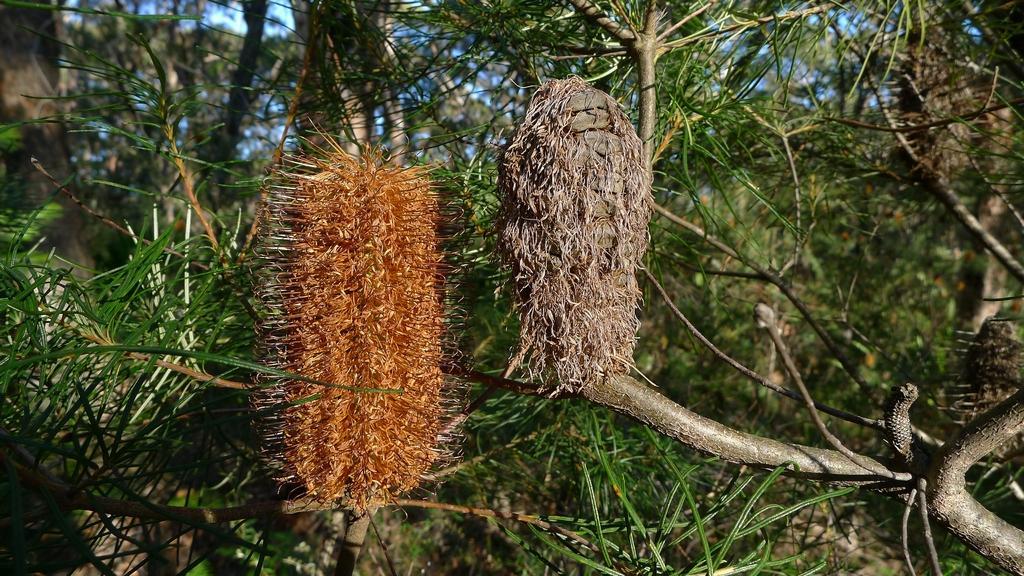In one or two sentences, can you explain what this image depicts? In this image we can see group of leaves on stem of a plant. In the background we can see group of trees and sky. 